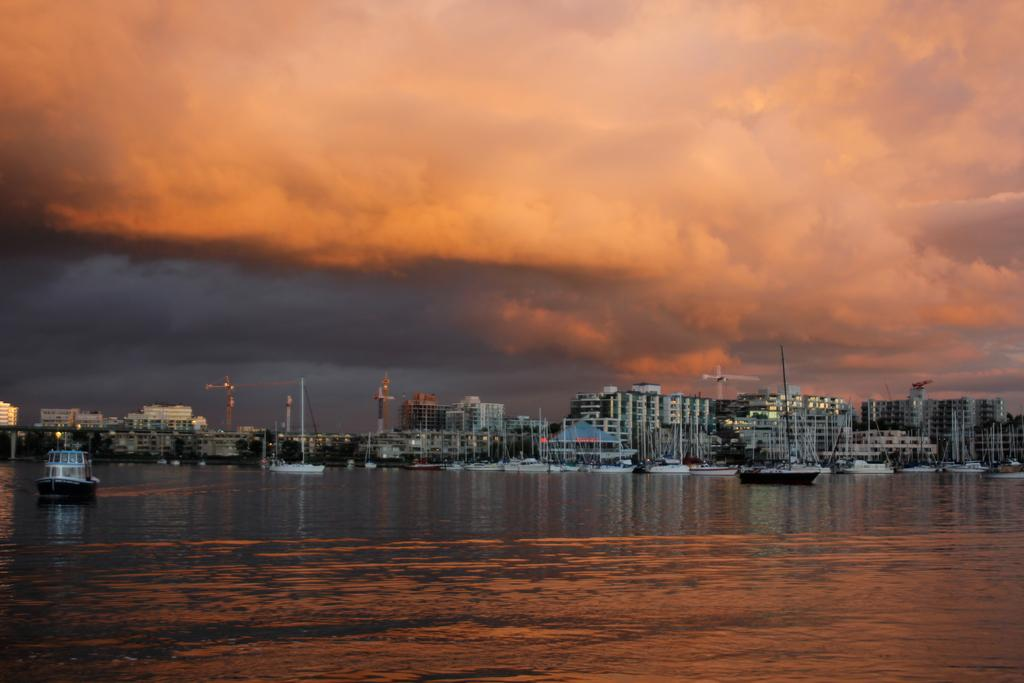What is located in the center of the image? There are buildings in the center of the image. What is at the bottom of the image? There is water at the bottom of the image. What can be seen floating on the water? Boats are visible on the water. What is visible in the background of the image? There is sky visible in the background of the image. Where is the line of wine bottles in the image? There is no line of wine bottles present in the image. What type of drum can be seen being played in the image? There is no drum present in the image; it features buildings, water, boats, and sky. 